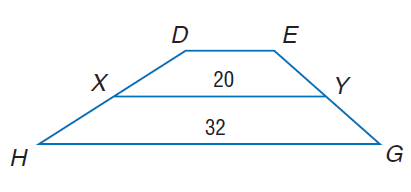Answer the mathemtical geometry problem and directly provide the correct option letter.
Question: For trapezoid D E G H, X and Y are midpoints of the legs. Find D E.
Choices: A: 8 B: 16 C: 20 D: 32 A 